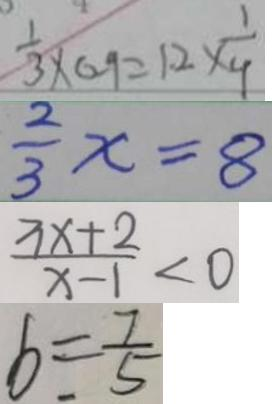Convert formula to latex. <formula><loc_0><loc_0><loc_500><loc_500>\frac { 1 } { 3 } \times 0 . 9 = 1 . 2 \times \frac { 1 } { 4 } 
 \frac { 2 } { 3 } x = 8 
 \frac { 3 x + 2 } { x - 1 } < 0 
 b = \frac { 7 } { 5 }</formula> 